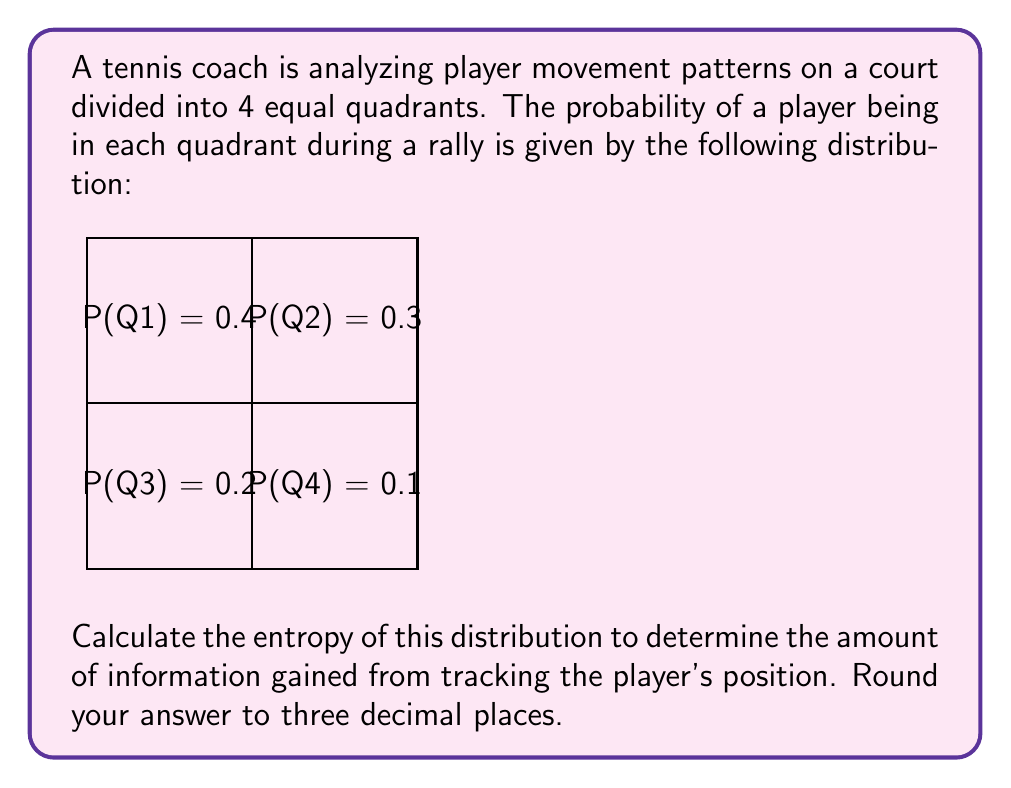Solve this math problem. To solve this problem, we need to use the entropy formula from information theory:

$$H = -\sum_{i=1}^n p_i \log_2(p_i)$$

Where $H$ is the entropy, $p_i$ is the probability of each event, and $n$ is the number of possible events.

Let's calculate each term:

1. For Q1: $-0.4 \log_2(0.4)$
   $= -0.4 \times (-1.321928) = 0.528771$

2. For Q2: $-0.3 \log_2(0.3)$
   $= -0.3 \times (-1.736966) = 0.521090$

3. For Q3: $-0.2 \log_2(0.2)$
   $= -0.2 \times (-2.321928) = 0.464386$

4. For Q4: $-0.1 \log_2(0.1)$
   $= -0.1 \times (-3.321928) = 0.332193$

Now, sum all these terms:

$H = 0.528771 + 0.521090 + 0.464386 + 0.332193 = 1.846440$

Rounding to three decimal places: 1.846

This value represents the average amount of information gained from knowing the player's position, measured in bits.
Answer: 1.846 bits 